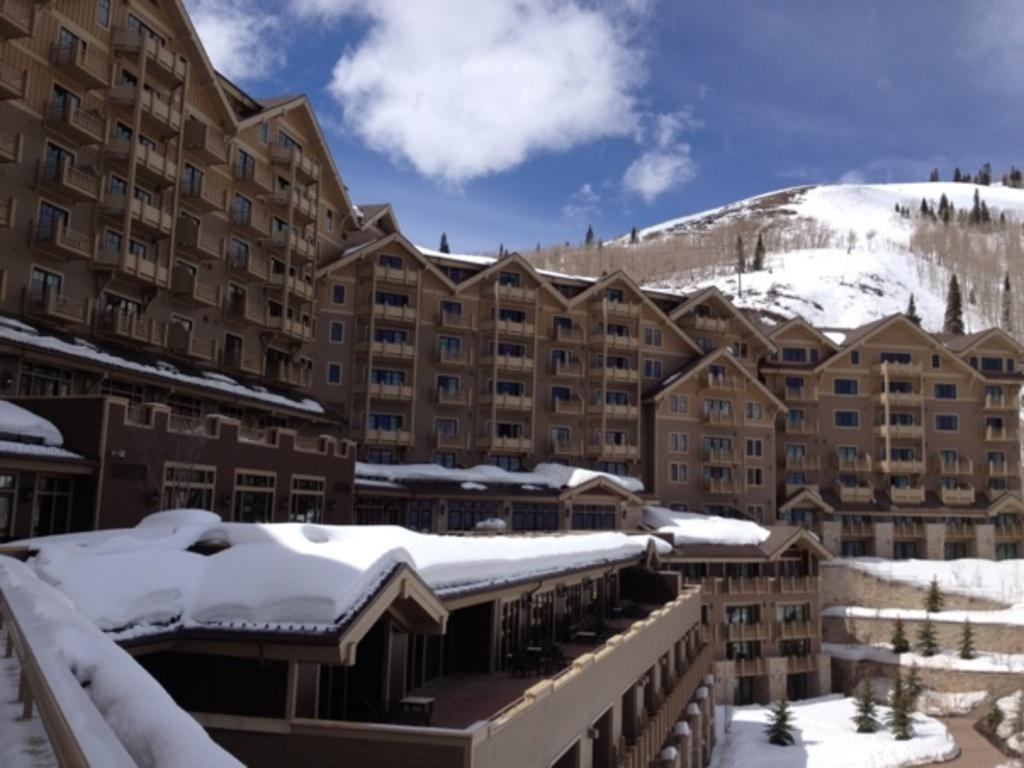What is the main structure in the image? There is a huge building in the image. What type of natural elements can be seen in the image? There are trees and mountains in the image. What is the weather like in the image? There is snow visible in the image, indicating a cold or snowy environment. What part of the natural environment is visible in the image? The sky is visible in the image. Where is the crow sitting on the bed in the image? There is no crow or bed present in the image. What type of glove is being used to catch snowflakes in the image? There is no glove or activity involving snowflakes present in the image. 